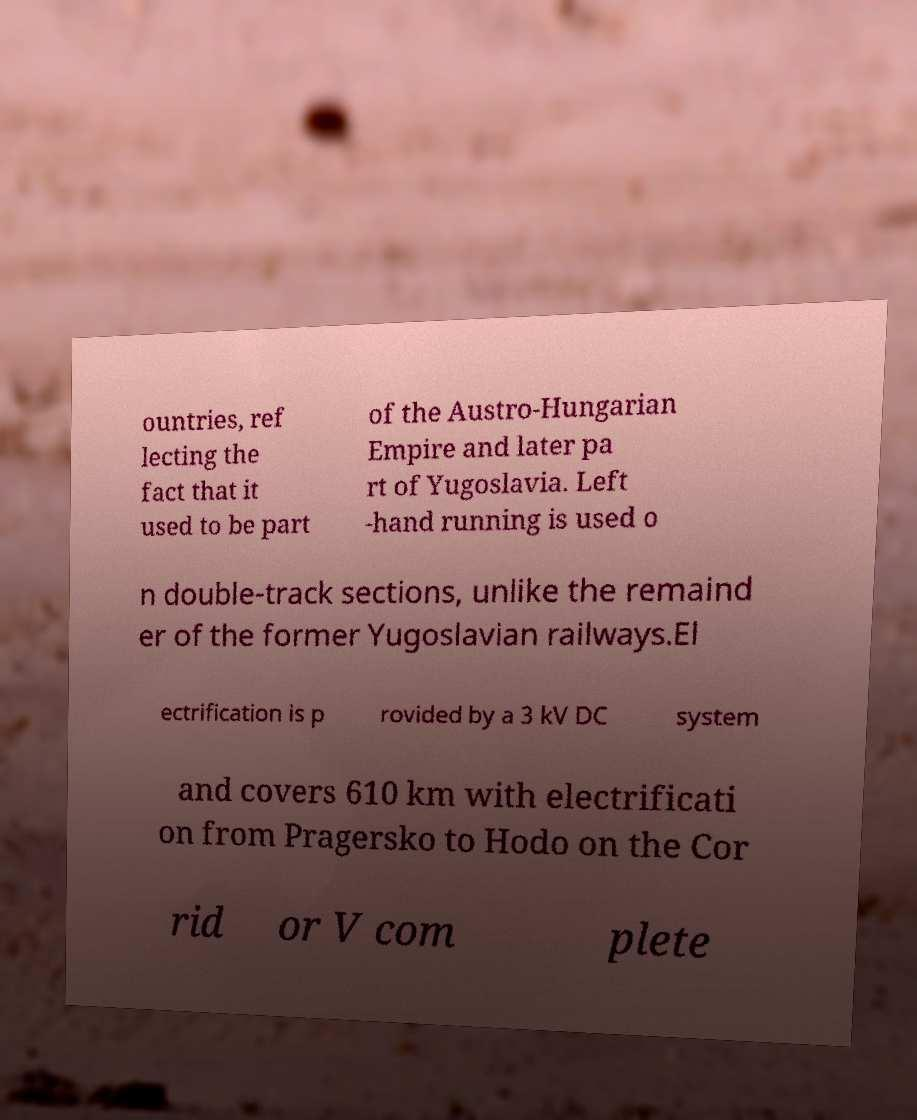Can you read and provide the text displayed in the image?This photo seems to have some interesting text. Can you extract and type it out for me? ountries, ref lecting the fact that it used to be part of the Austro-Hungarian Empire and later pa rt of Yugoslavia. Left -hand running is used o n double-track sections, unlike the remaind er of the former Yugoslavian railways.El ectrification is p rovided by a 3 kV DC system and covers 610 km with electrificati on from Pragersko to Hodo on the Cor rid or V com plete 